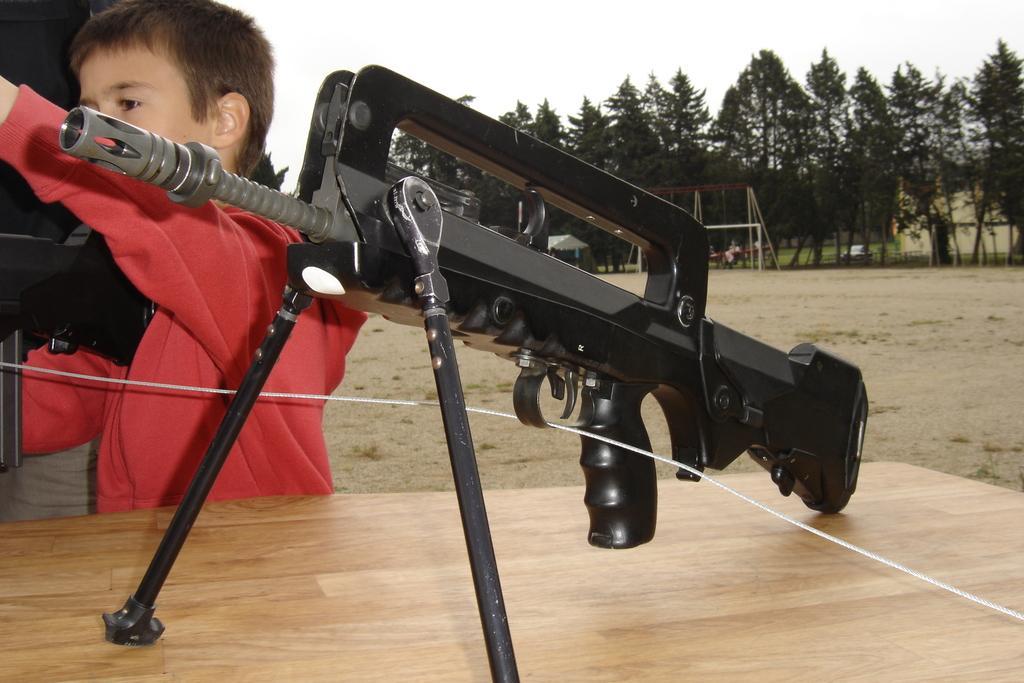Can you describe this image briefly? In this image we can see a shooting gun on the table and to the side, we can see a boy. In the background, we can see some trees and the sky. We can also see there is a tent and a house and some other objects. 